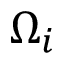<formula> <loc_0><loc_0><loc_500><loc_500>\Omega _ { i }</formula> 